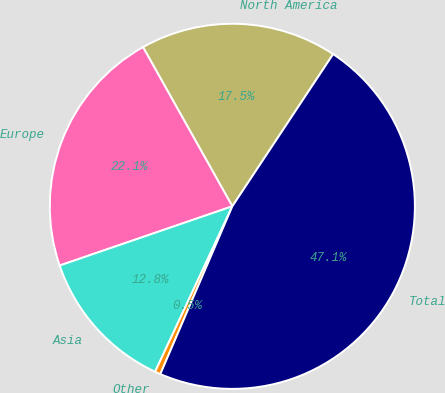<chart> <loc_0><loc_0><loc_500><loc_500><pie_chart><fcel>North America<fcel>Europe<fcel>Asia<fcel>Other<fcel>Total<nl><fcel>17.45%<fcel>22.12%<fcel>12.79%<fcel>0.5%<fcel>47.14%<nl></chart> 